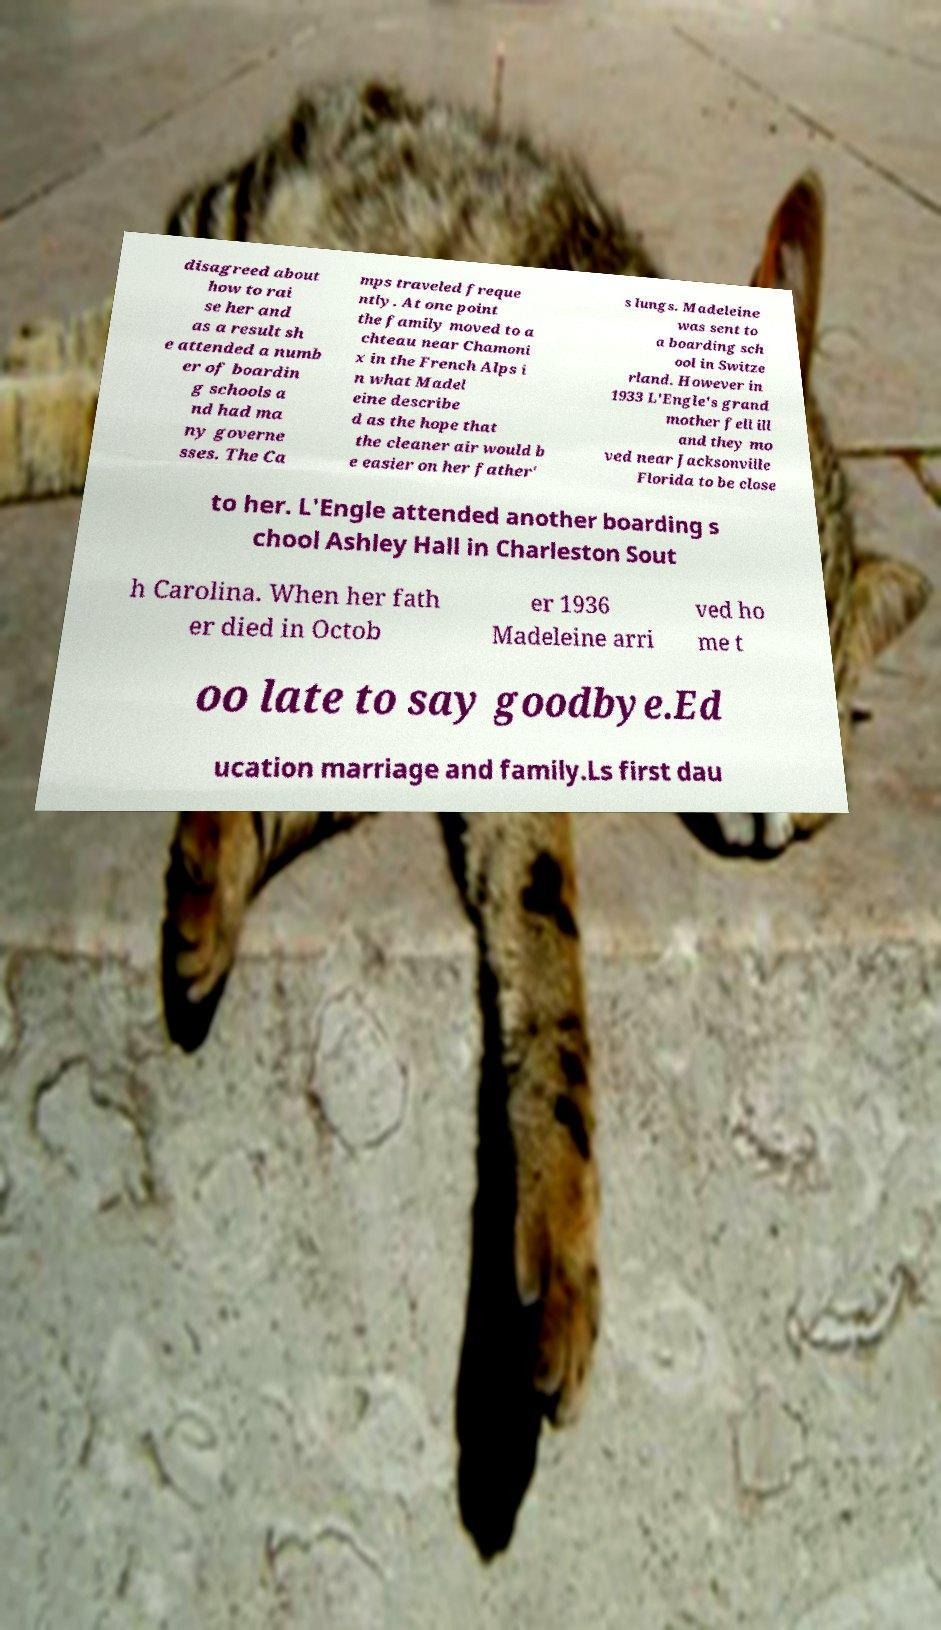I need the written content from this picture converted into text. Can you do that? disagreed about how to rai se her and as a result sh e attended a numb er of boardin g schools a nd had ma ny governe sses. The Ca mps traveled freque ntly. At one point the family moved to a chteau near Chamoni x in the French Alps i n what Madel eine describe d as the hope that the cleaner air would b e easier on her father' s lungs. Madeleine was sent to a boarding sch ool in Switze rland. However in 1933 L'Engle's grand mother fell ill and they mo ved near Jacksonville Florida to be close to her. L'Engle attended another boarding s chool Ashley Hall in Charleston Sout h Carolina. When her fath er died in Octob er 1936 Madeleine arri ved ho me t oo late to say goodbye.Ed ucation marriage and family.Ls first dau 